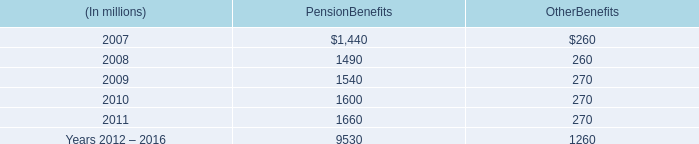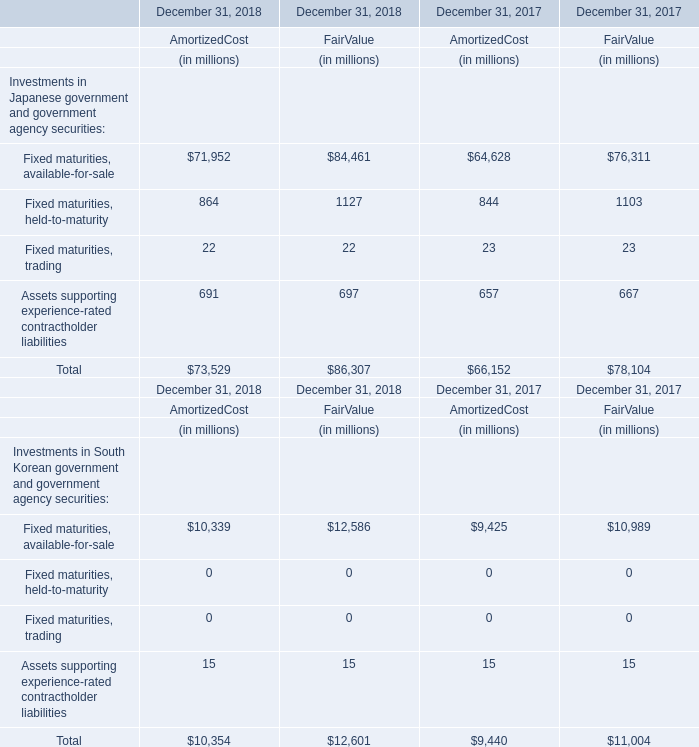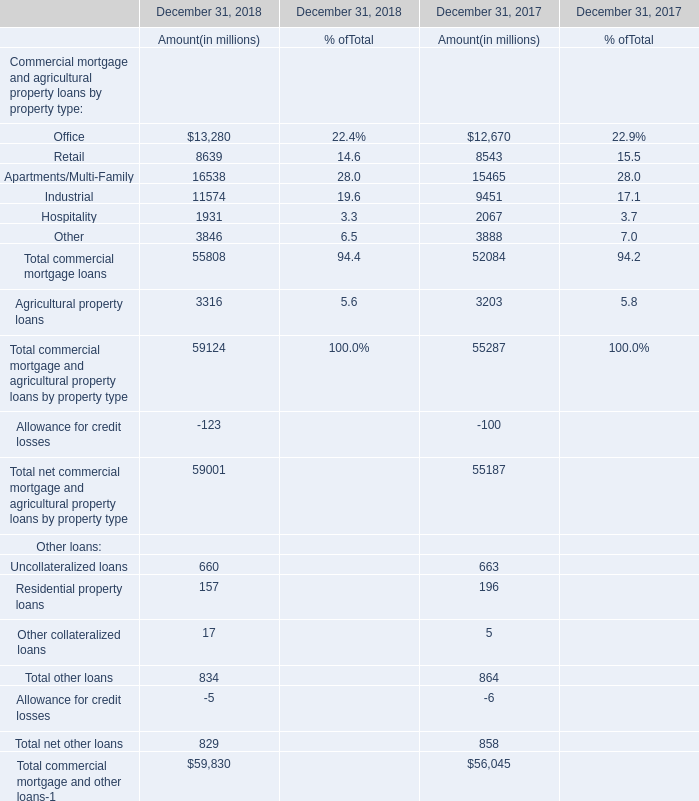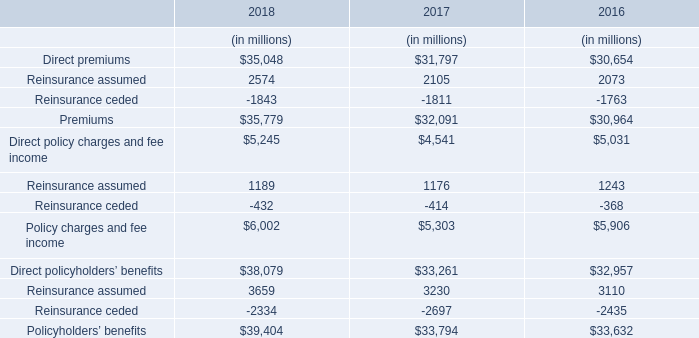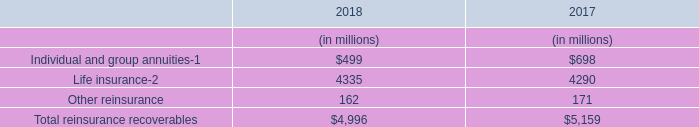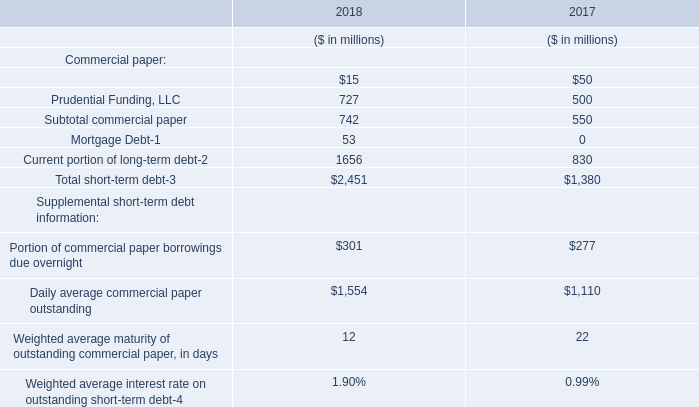what percentage of future minimum lease commitments at december 31 , 2006 for all operating leases that have a remaining term of more than one year are due in 2007? 
Computations: (288 / (1.1 * 1000))
Answer: 0.26182. 